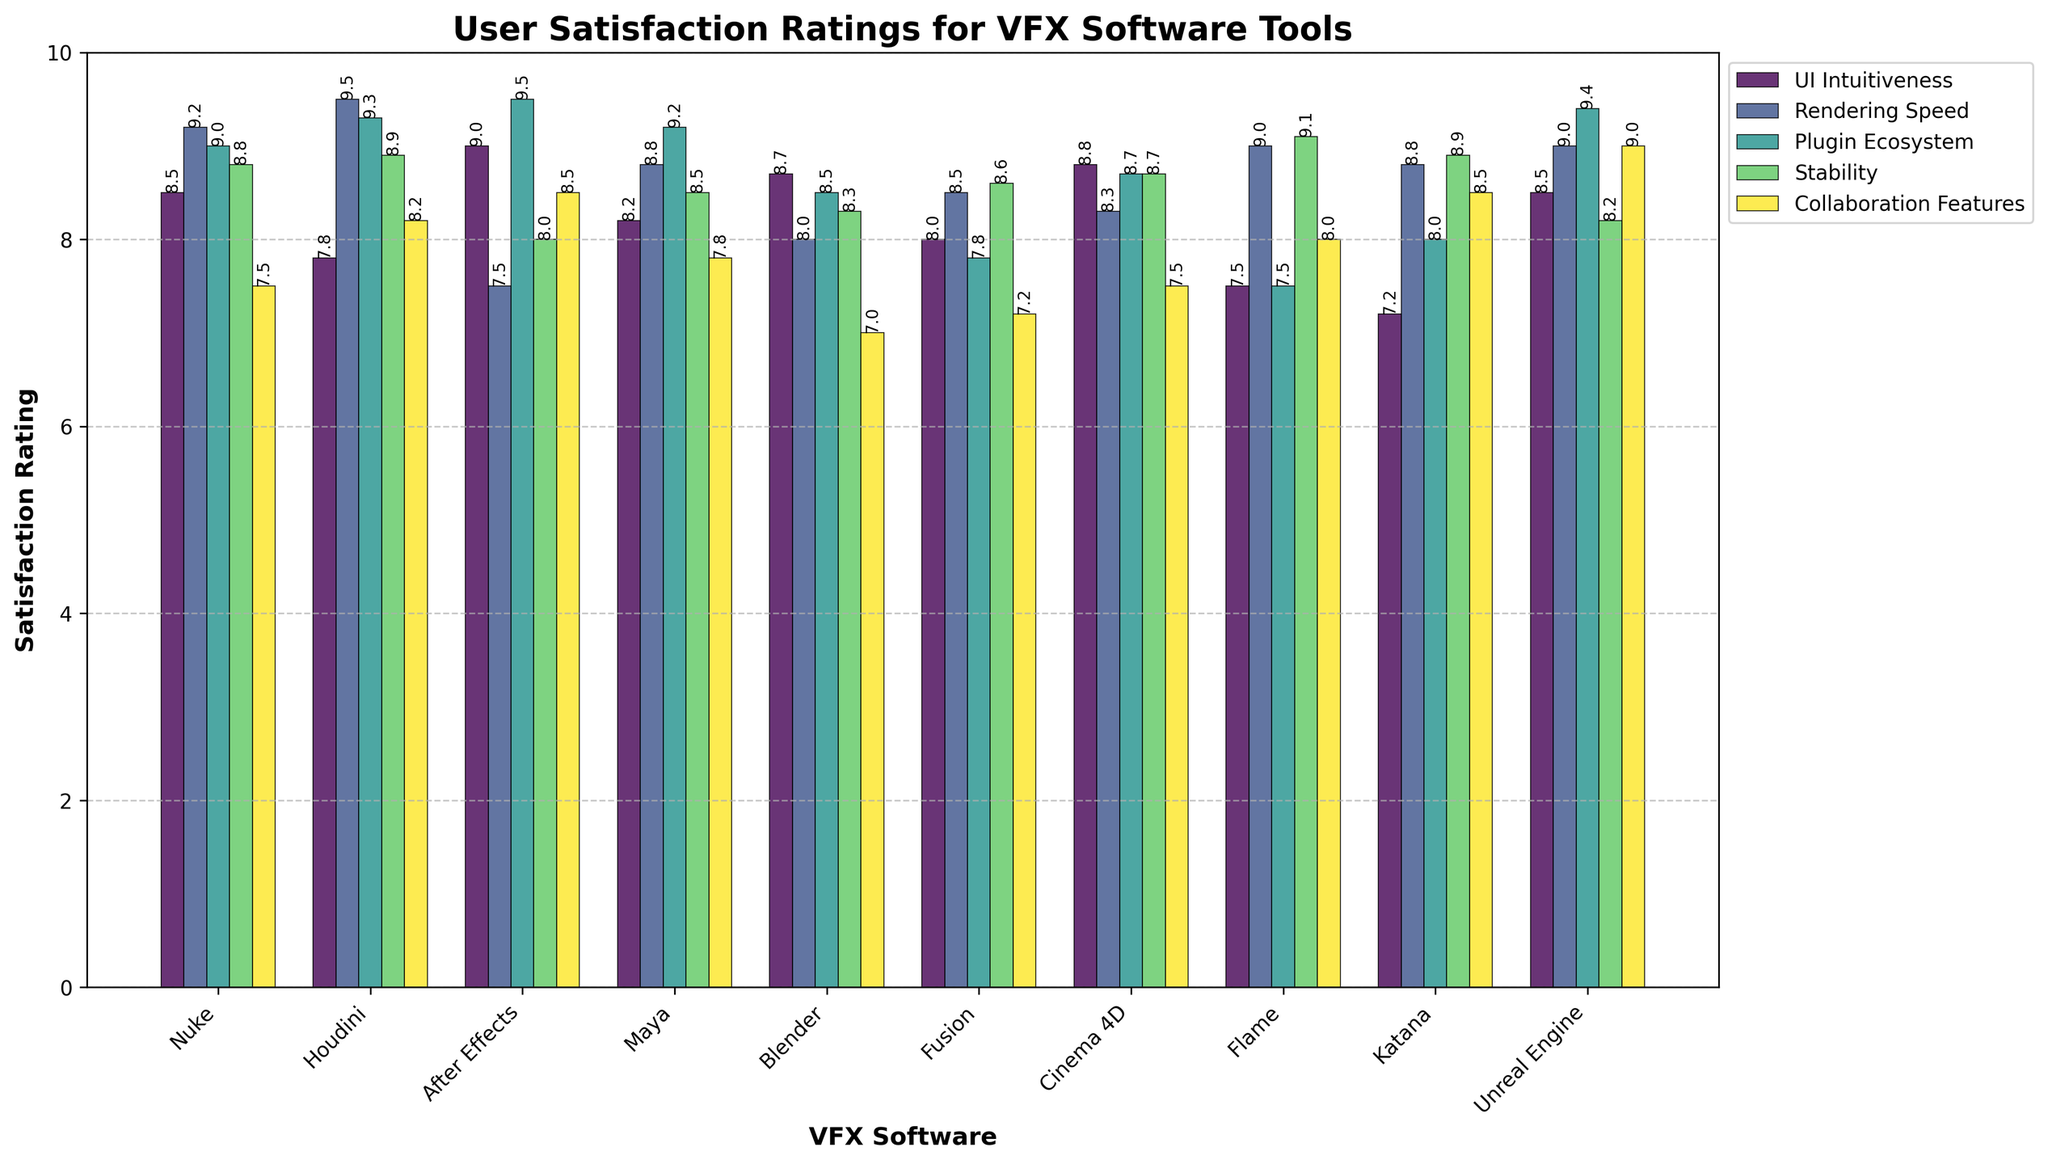What's the highest user satisfaction rating for UI Intuitiveness, and which software has it? Identify the tallest bar in the UI Intuitiveness category, which corresponds to the highest rating. Based on the data, the highest rating for UI Intuitiveness is 9.0, attributed to After Effects.
Answer: 9.0, After Effects Which software has the lowest rating in Collaboration Features? Find the shortest bar in the Collaboration Features category. According to the data, Blender has the lowest rating in Collaboration Features with a score of 7.0.
Answer: Blender Compare the median Rendering Speed rating between Nuke, Blender, Maya, and Flame. Which software has the highest median? Extract the Rendering Speed ratings for Nuke, Blender, Maya, and Flame (9.2, 8.0, 8.8, 9.0), and then sort these values. The median value of this sorted list (8.0, 8.8, 9.0, 9.2) is the second highest score, 8.9, which both Nuke and Flame are slightly higher than.
Answer: Nuke Which software shows a higher average rating across all features: Cinema 4D or Fusion? Calculate the average of all features for Cinema 4D and Fusion: Cinema 4D (8.8 + 8.3 + 8.7 + 8.7 + 7.5)/5 = 8.4, Fusion (8.0 + 8.5 + 7.8 + 8.6 + 7.2)/5 = 8.02. Cinema 4D has the higher average rating.
Answer: Cinema 4D How does Unreal Engine's Collaboration Features rating compare to Katana's? Identify and compare the heights of the bars for Collaboration Features in Unreal Engine and Katana. According to the data, Unreal Engine has a rating of 9.0, whereas Katana has a rating of 8.5. Unreal Engine scores higher.
Answer: Unreal Engine Which software has the highest overall satisfaction in Stability, and what's the value? Look for the highest bar in the Stability category. According to the data, Flame has the highest Stability rating with a score of 9.1.
Answer: Flame, 9.1 Is Houdini rated higher than After Effects in the Plugin Ecosystem? Compare the bars for Houdini and After Effects under the Plugin Ecosystem category. Houdini has a rating of 9.3, whereas After Effects has a higher rating of 9.5.
Answer: No What is the combined satisfaction score for Rendering Speed and Stability in Maya? Add Maya's ratings for Rendering Speed and Stability: 8.8 (Rendering Speed) + 8.5 (Stability) = 17.3.
Answer: 17.3 Which software features the most balanced ratings across all key features, indicated by the least variation in bar heights? Visually inspect the bar heights for each software to identify the one with the most uniform heights across all categories. For Fusion, the ratings are relatively balanced: 8.0, 8.5, 7.8, 8.6, and 7.2.
Answer: Fusion How does the user satisfaction of Blender's UI Intuitiveness compare to Cinema 4D's UI Intuitiveness? Compare the bar height for UI Intuitiveness of Blender and Cinema 4D. Blender has a rating of 8.7, slightly less than Cinema 4D's rating of 8.8.
Answer: Blender 